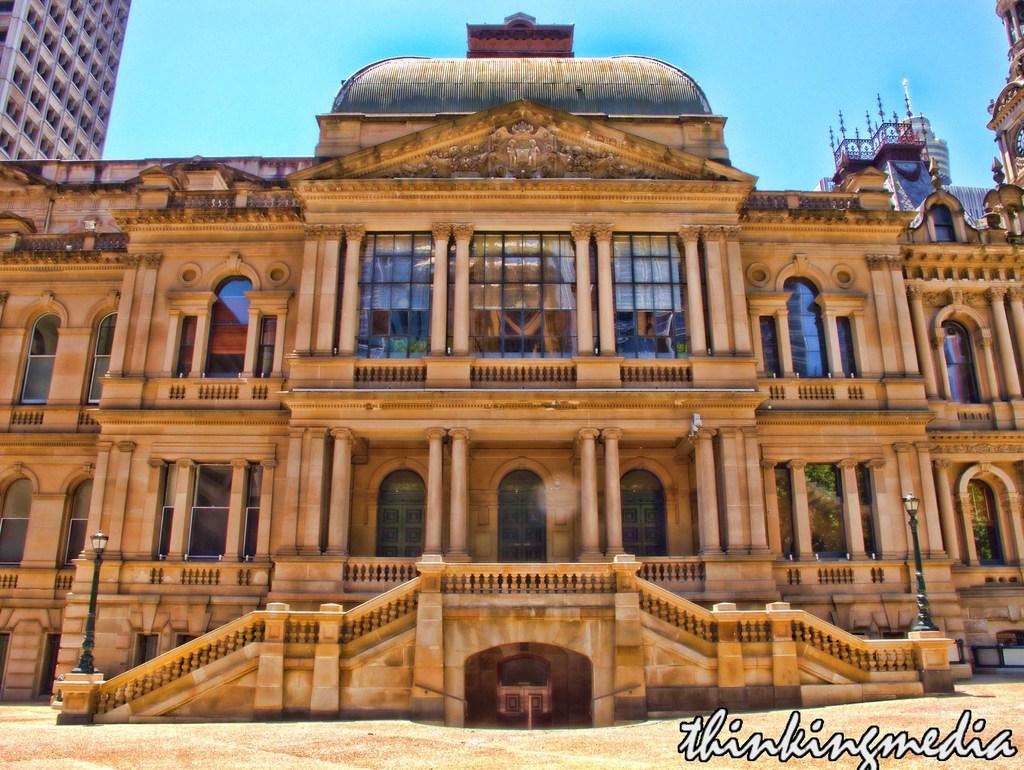<image>
Provide a brief description of the given image. A beige building with "Thinking Media" written below it. 